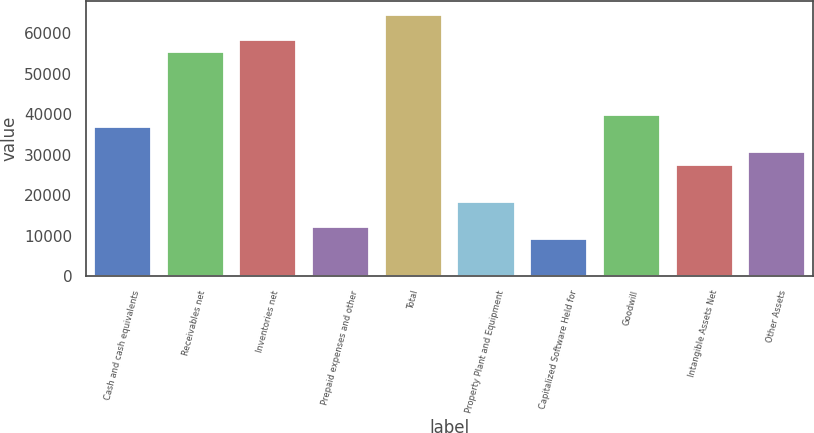Convert chart. <chart><loc_0><loc_0><loc_500><loc_500><bar_chart><fcel>Cash and cash equivalents<fcel>Receivables net<fcel>Inventories net<fcel>Prepaid expenses and other<fcel>Total<fcel>Property Plant and Equipment<fcel>Capitalized Software Held for<fcel>Goodwill<fcel>Intangible Assets Net<fcel>Other Assets<nl><fcel>37062.4<fcel>55591.6<fcel>58679.8<fcel>12356.8<fcel>64856.2<fcel>18533.2<fcel>9268.6<fcel>40150.6<fcel>27797.8<fcel>30886<nl></chart> 